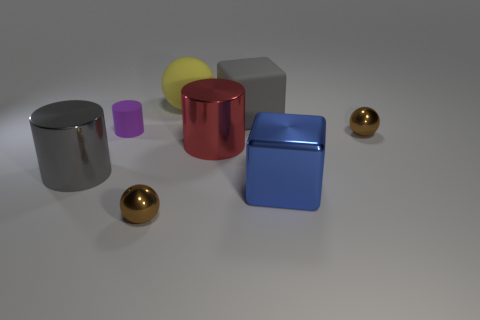How big is the red metallic cylinder that is behind the large cube that is in front of the gray object on the right side of the yellow sphere? The red metallic cylinder behind the large cube appears to have a height approximately equal to the cube's edge length. The cylinder's diameter cannot be precisely determined from this perspective, but it seems proportionate in size to other objects in the scene. 